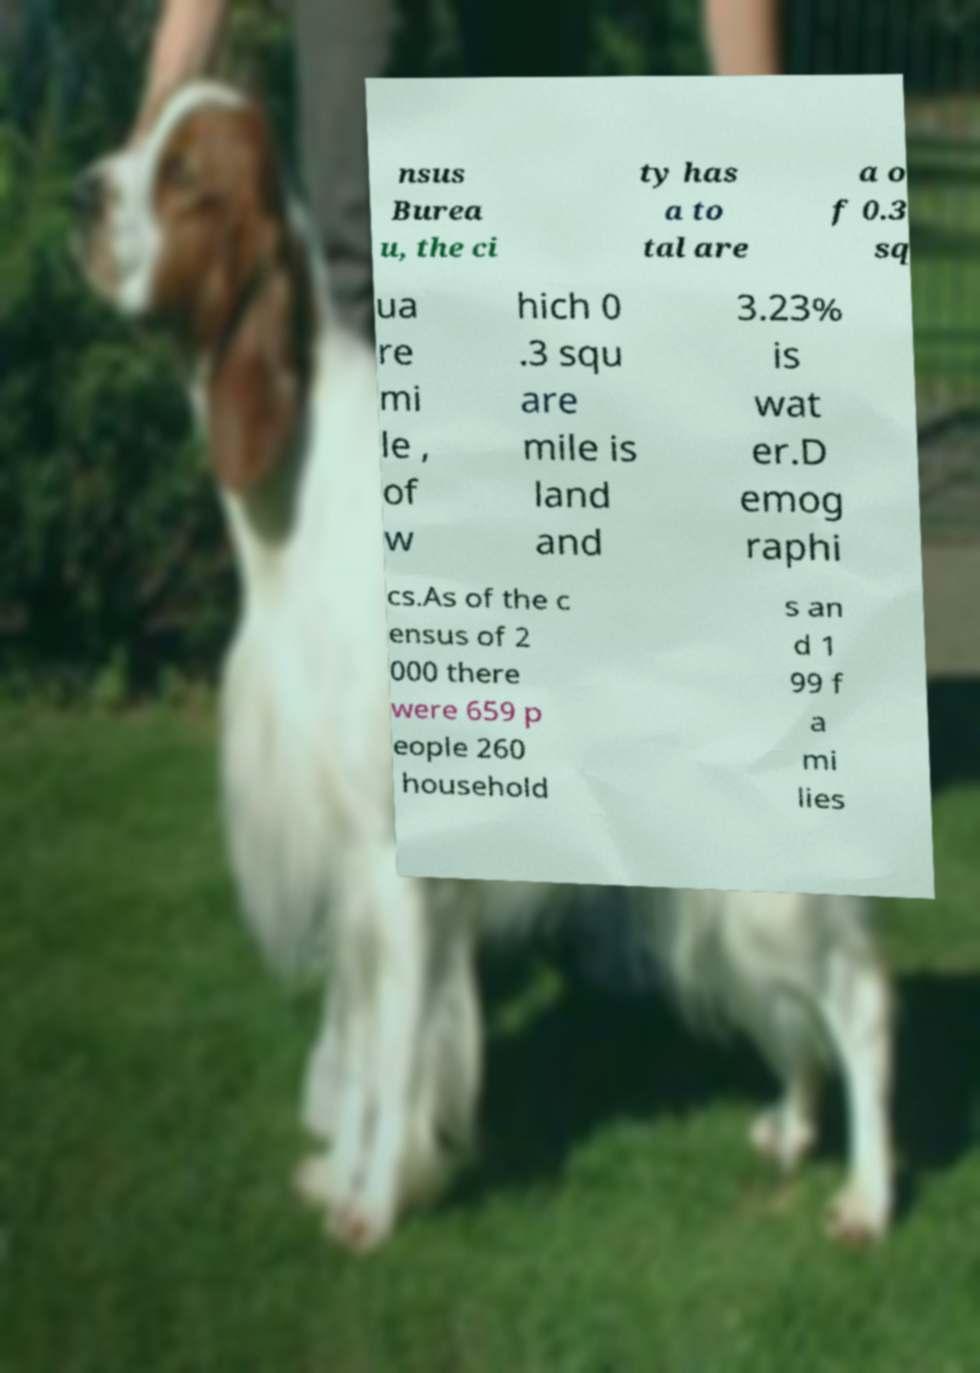Could you assist in decoding the text presented in this image and type it out clearly? nsus Burea u, the ci ty has a to tal are a o f 0.3 sq ua re mi le , of w hich 0 .3 squ are mile is land and 3.23% is wat er.D emog raphi cs.As of the c ensus of 2 000 there were 659 p eople 260 household s an d 1 99 f a mi lies 